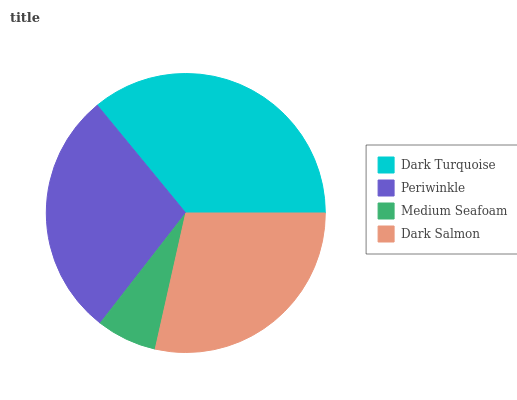Is Medium Seafoam the minimum?
Answer yes or no. Yes. Is Dark Turquoise the maximum?
Answer yes or no. Yes. Is Periwinkle the minimum?
Answer yes or no. No. Is Periwinkle the maximum?
Answer yes or no. No. Is Dark Turquoise greater than Periwinkle?
Answer yes or no. Yes. Is Periwinkle less than Dark Turquoise?
Answer yes or no. Yes. Is Periwinkle greater than Dark Turquoise?
Answer yes or no. No. Is Dark Turquoise less than Periwinkle?
Answer yes or no. No. Is Periwinkle the high median?
Answer yes or no. Yes. Is Dark Salmon the low median?
Answer yes or no. Yes. Is Dark Turquoise the high median?
Answer yes or no. No. Is Periwinkle the low median?
Answer yes or no. No. 